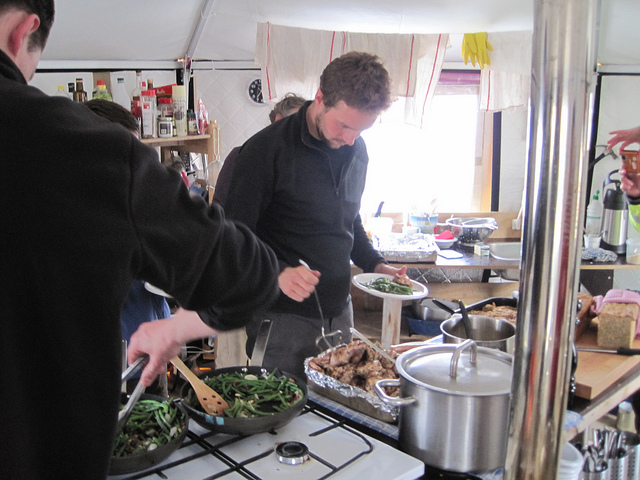<image>What vegetable is the man cutting? It is unclear what vegetable the man is cutting. It could be greens or green beans. What vegetable is the man cutting? I am not sure what vegetable the man is cutting. It can be either greens or green beans. 